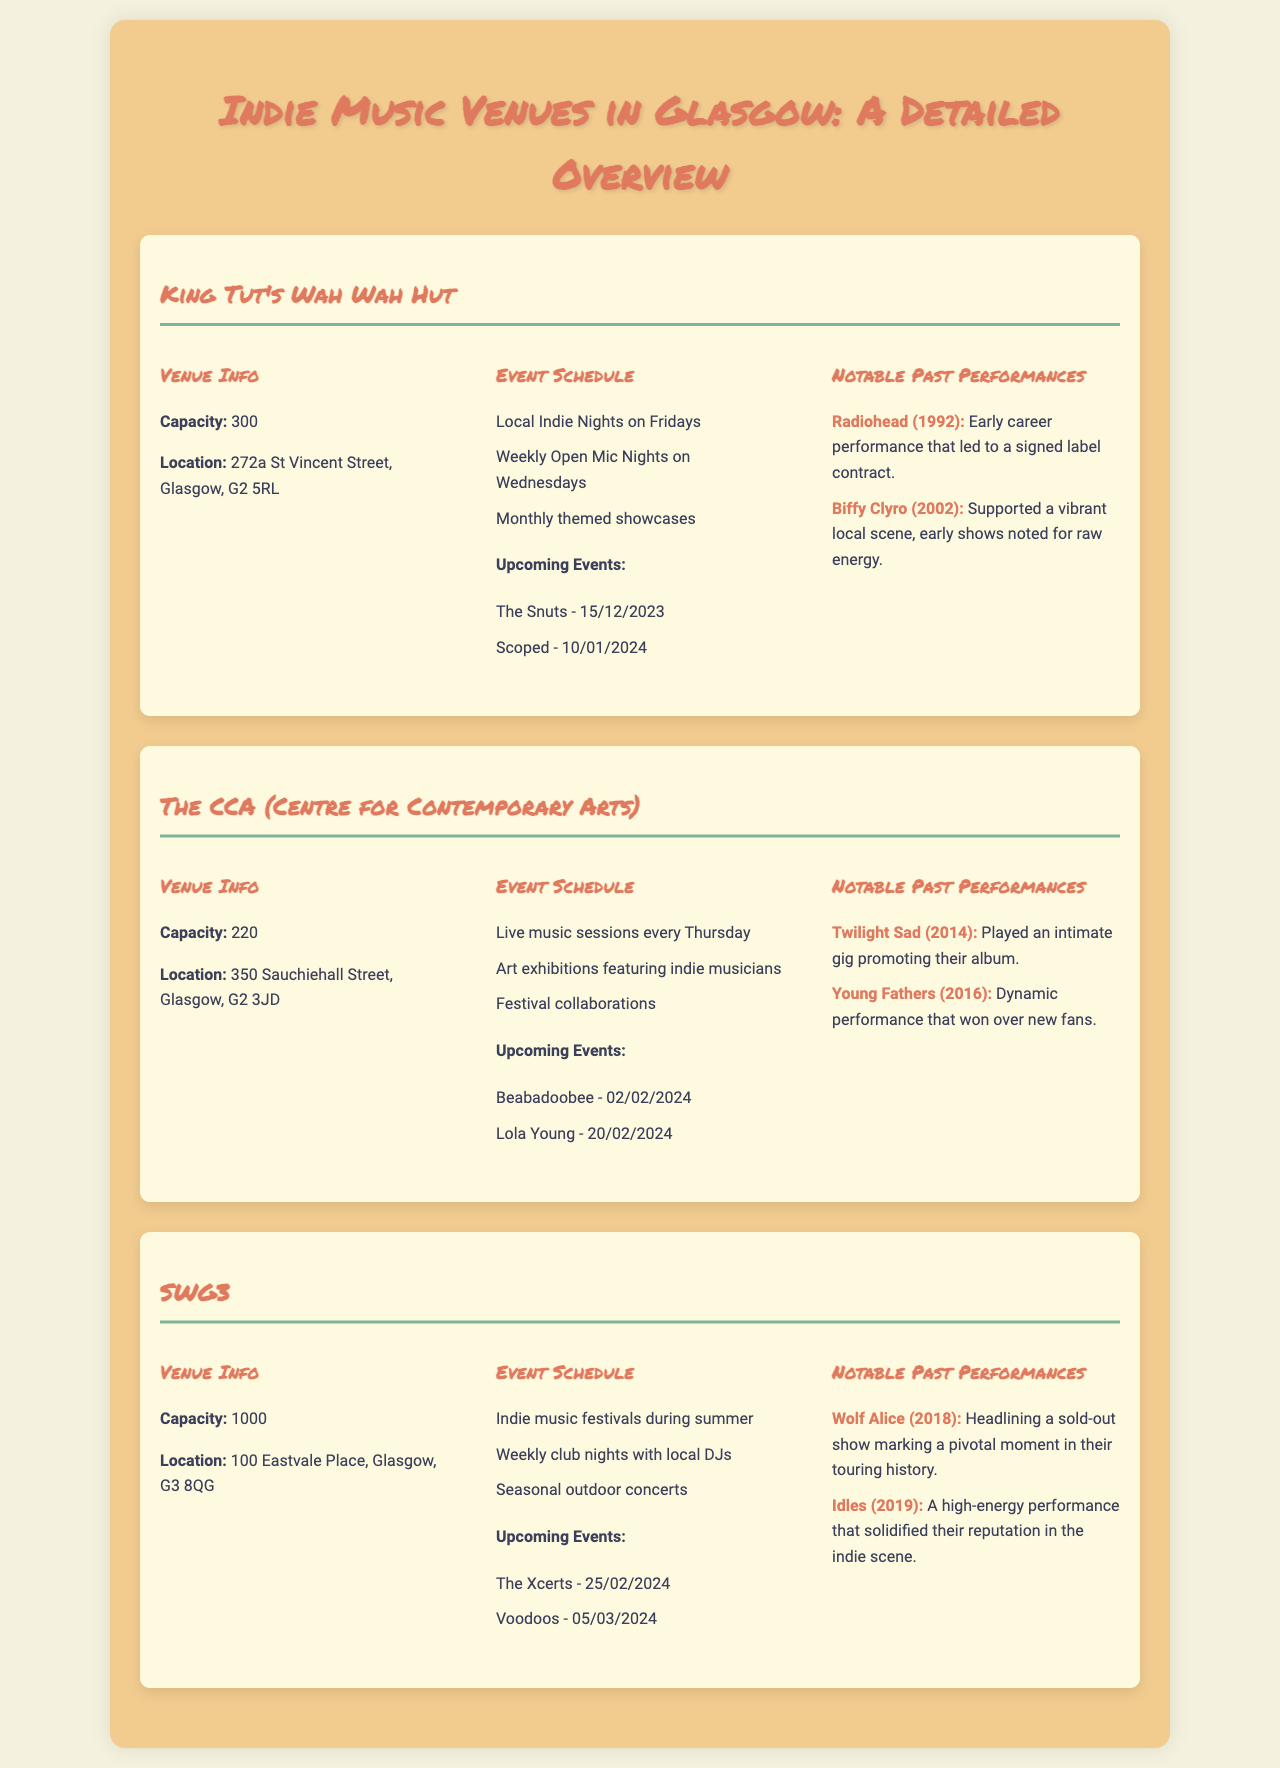What is the capacity of King Tut's Wah Wah Hut? The capacity of King Tut's Wah Wah Hut is specified in the venue info section.
Answer: 300 Where is The CCA located? The location of The CCA is given in the venue info section of the document.
Answer: 350 Sauchiehall Street, Glasgow, G2 3JD When is the upcoming event for Beabadoobee? Beabadoobee's upcoming event date is listed under the event schedule for The CCA.
Answer: 02/02/2024 Which artist performed at SWG3 in 2018? The notable past performances at SWG3 include the artist mentioned alongside the year in the document.
Answer: Wolf Alice What type of events happen every Wednesday at King Tut's Wah Wah Hut? The type of events that occur weekly is mentioned under the event schedule for King Tut's Wah Wah Hut.
Answer: Open Mic Nights What is the highest capacity among the venues listed? The highest capacity can be determined by comparing the capacity figures provided for each venue in the document.
Answer: 1000 What notable performance did Twilight Sad have in 2014? The notable past performances for The CCA detail the specific event for Twilight Sad in the mentioned year.
Answer: Intimate gig promoting their album How often do local indie nights take place at King Tut's Wah Wah Hut? The frequency of local indie nights is stated in the event schedule for King Tut's Wah Wah Hut.
Answer: Fridays What are the notable past performances mentioned for The CCA? The document lists two specific past performances for The CCA under the notable past performances section.
Answer: Twilight Sad, Young Fathers 